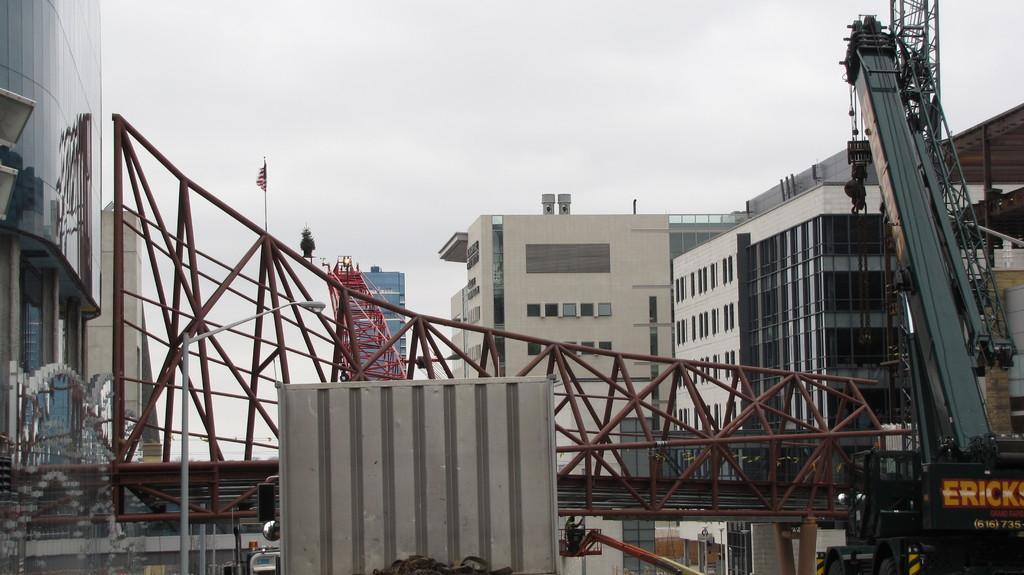Could you give a brief overview of what you see in this image? In this image, we can see some buildings and cranes. We can see some metal objects and the sky. We can see a flag and a board with some text. 